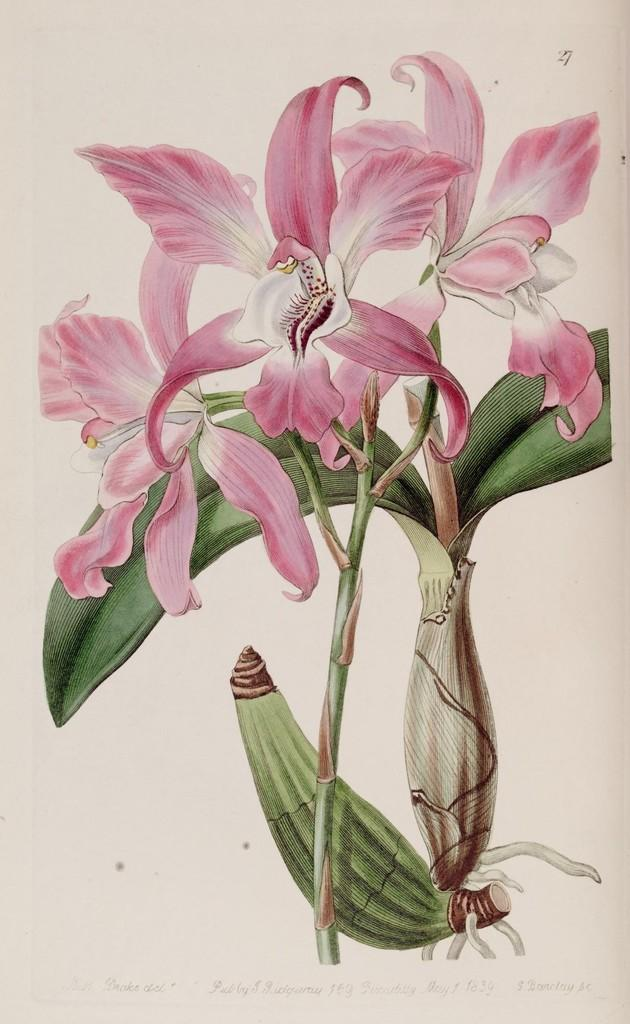What type of artwork is shown in the image? The image is a painting. What is the main subject of the painting? The painting depicts a flower. Where is the stamp located in the painting? There is no stamp present in the painting; it is a depiction of a flower. What advice might the dad give about the flower in the painting? There is no dad present in the painting, nor is there any indication of advice being given. 